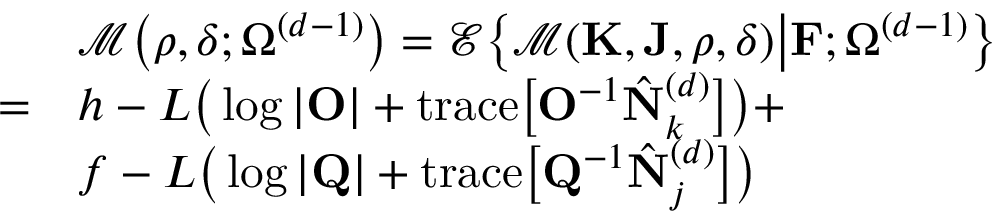Convert formula to latex. <formula><loc_0><loc_0><loc_500><loc_500>\begin{array} { r l } & { \mathcal { M } \Big ( \rho , \delta ; \Omega ^ { ( d - 1 ) } \Big ) = \mathcal { E } \Big \{ \mathcal { M } ( K , J , \rho , \delta ) \Big | F ; \Omega ^ { ( d - 1 ) } \Big \} } \\ { = } & { h - L \Big ( \log | O | + t r a c e \Big [ O ^ { - 1 } \hat { N } _ { k } ^ { ( d ) } \Big ] \Big ) + } \\ & { f - L \Big ( \log | Q | + t r a c e \Big [ Q ^ { - 1 } \hat { N } _ { j } ^ { ( d ) } \Big ] \Big ) } \end{array}</formula> 